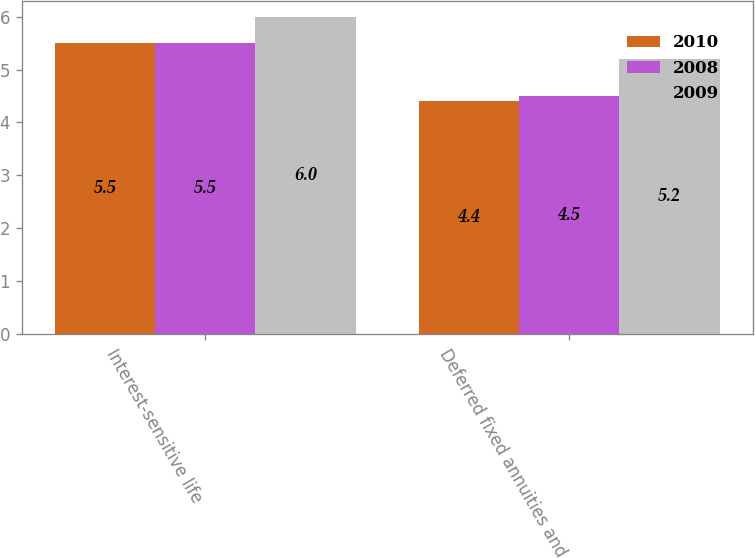Convert chart to OTSL. <chart><loc_0><loc_0><loc_500><loc_500><stacked_bar_chart><ecel><fcel>Interest-sensitive life<fcel>Deferred fixed annuities and<nl><fcel>2010<fcel>5.5<fcel>4.4<nl><fcel>2008<fcel>5.5<fcel>4.5<nl><fcel>2009<fcel>6<fcel>5.2<nl></chart> 